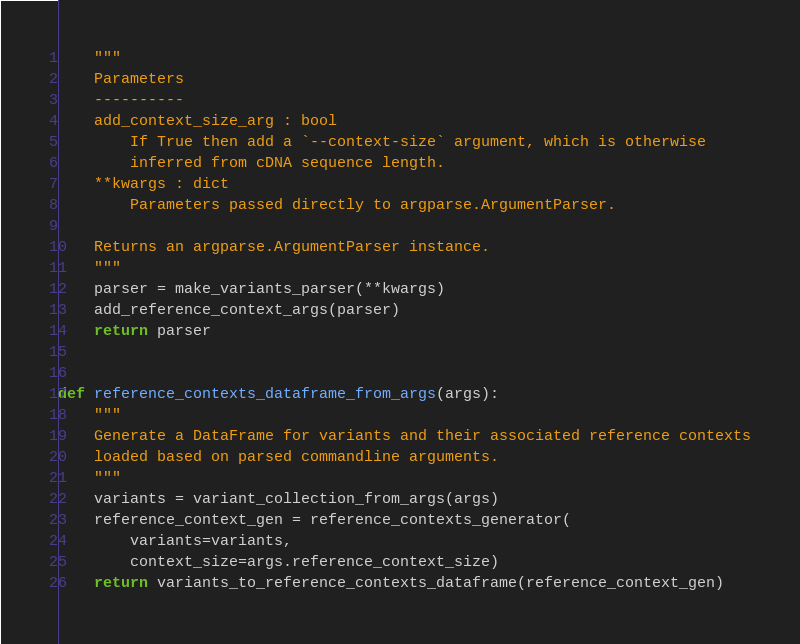Convert code to text. <code><loc_0><loc_0><loc_500><loc_500><_Python_>    """
    Parameters
    ----------
    add_context_size_arg : bool
        If True then add a `--context-size` argument, which is otherwise
        inferred from cDNA sequence length.
    **kwargs : dict
        Parameters passed directly to argparse.ArgumentParser.

    Returns an argparse.ArgumentParser instance.
    """
    parser = make_variants_parser(**kwargs)
    add_reference_context_args(parser)
    return parser


def reference_contexts_dataframe_from_args(args):
    """
    Generate a DataFrame for variants and their associated reference contexts
    loaded based on parsed commandline arguments.
    """
    variants = variant_collection_from_args(args)
    reference_context_gen = reference_contexts_generator(
        variants=variants,
        context_size=args.reference_context_size)
    return variants_to_reference_contexts_dataframe(reference_context_gen)
</code> 